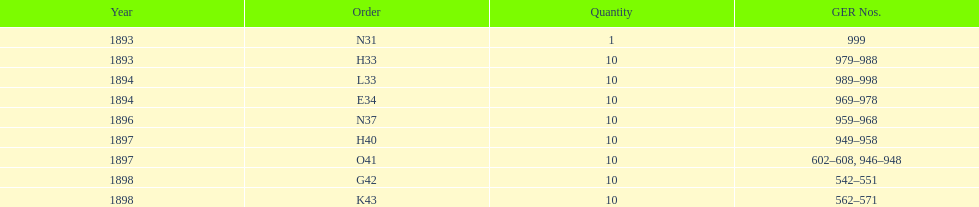What order is listed first at the top of the table? N31. 